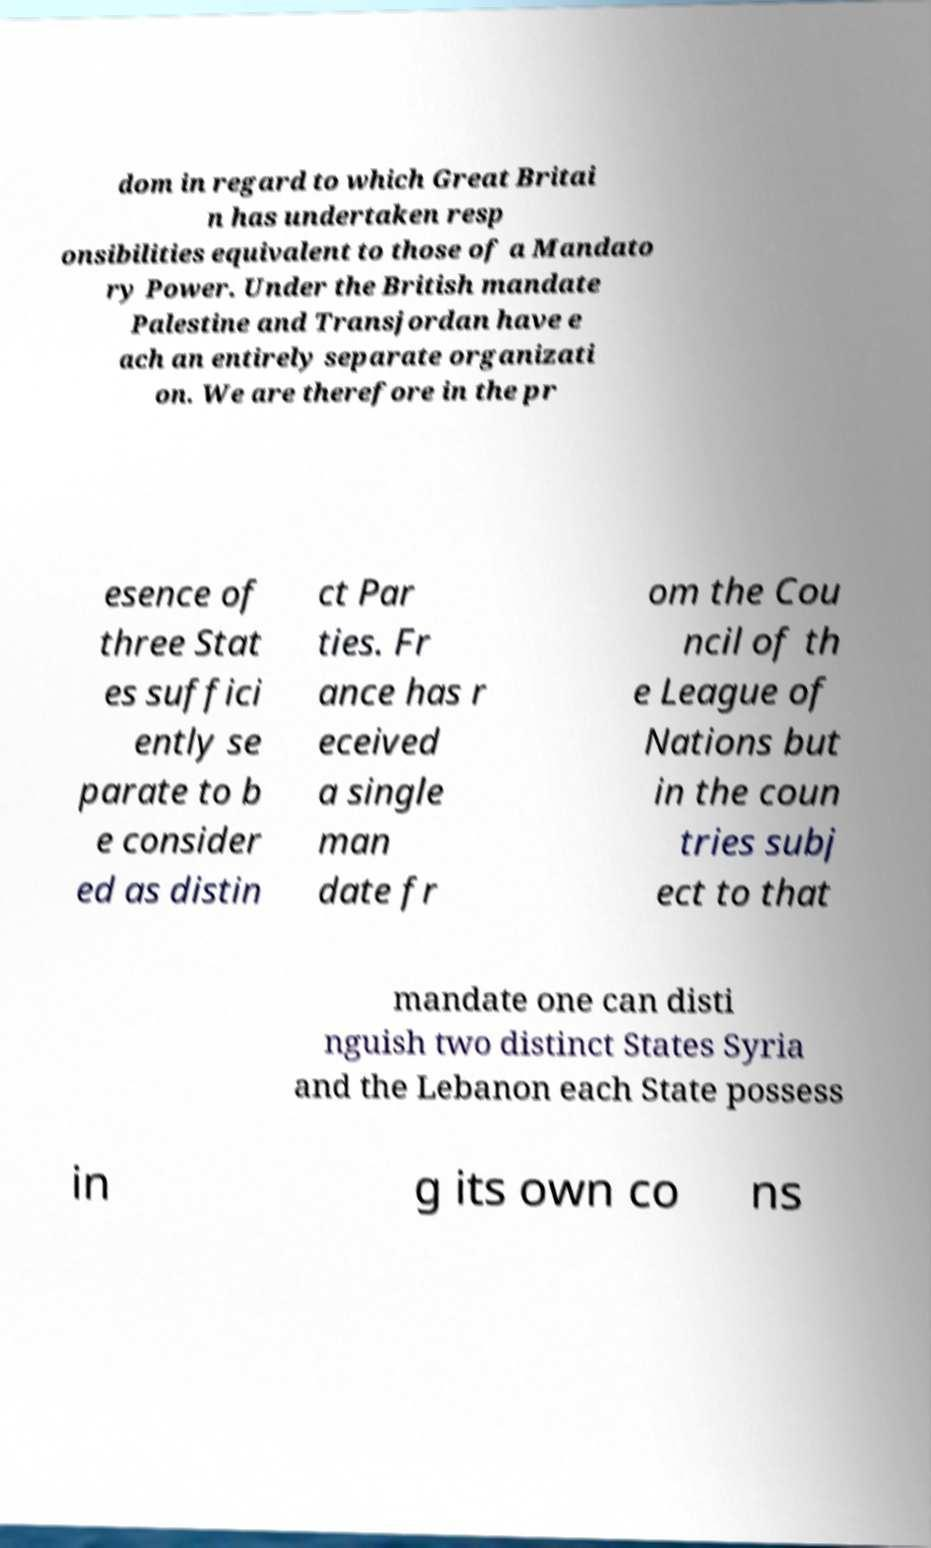Can you accurately transcribe the text from the provided image for me? dom in regard to which Great Britai n has undertaken resp onsibilities equivalent to those of a Mandato ry Power. Under the British mandate Palestine and Transjordan have e ach an entirely separate organizati on. We are therefore in the pr esence of three Stat es suffici ently se parate to b e consider ed as distin ct Par ties. Fr ance has r eceived a single man date fr om the Cou ncil of th e League of Nations but in the coun tries subj ect to that mandate one can disti nguish two distinct States Syria and the Lebanon each State possess in g its own co ns 